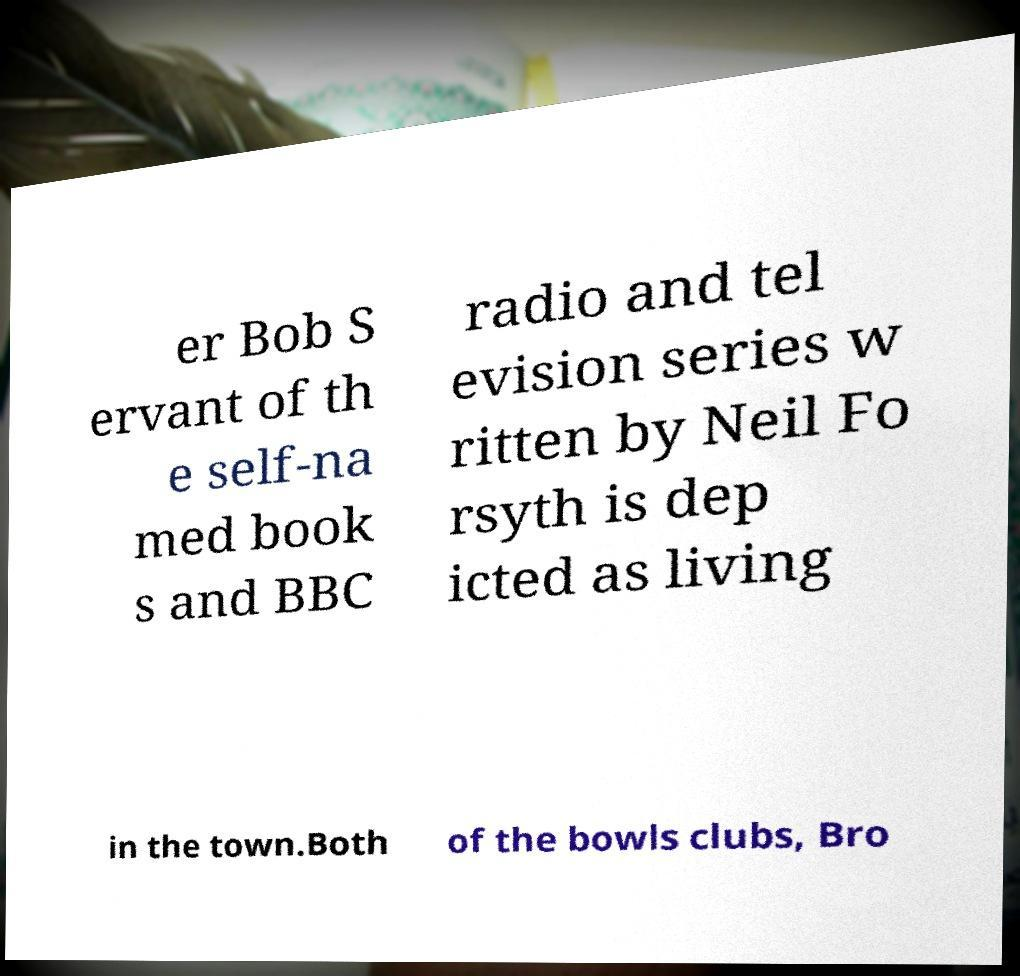I need the written content from this picture converted into text. Can you do that? er Bob S ervant of th e self-na med book s and BBC radio and tel evision series w ritten by Neil Fo rsyth is dep icted as living in the town.Both of the bowls clubs, Bro 